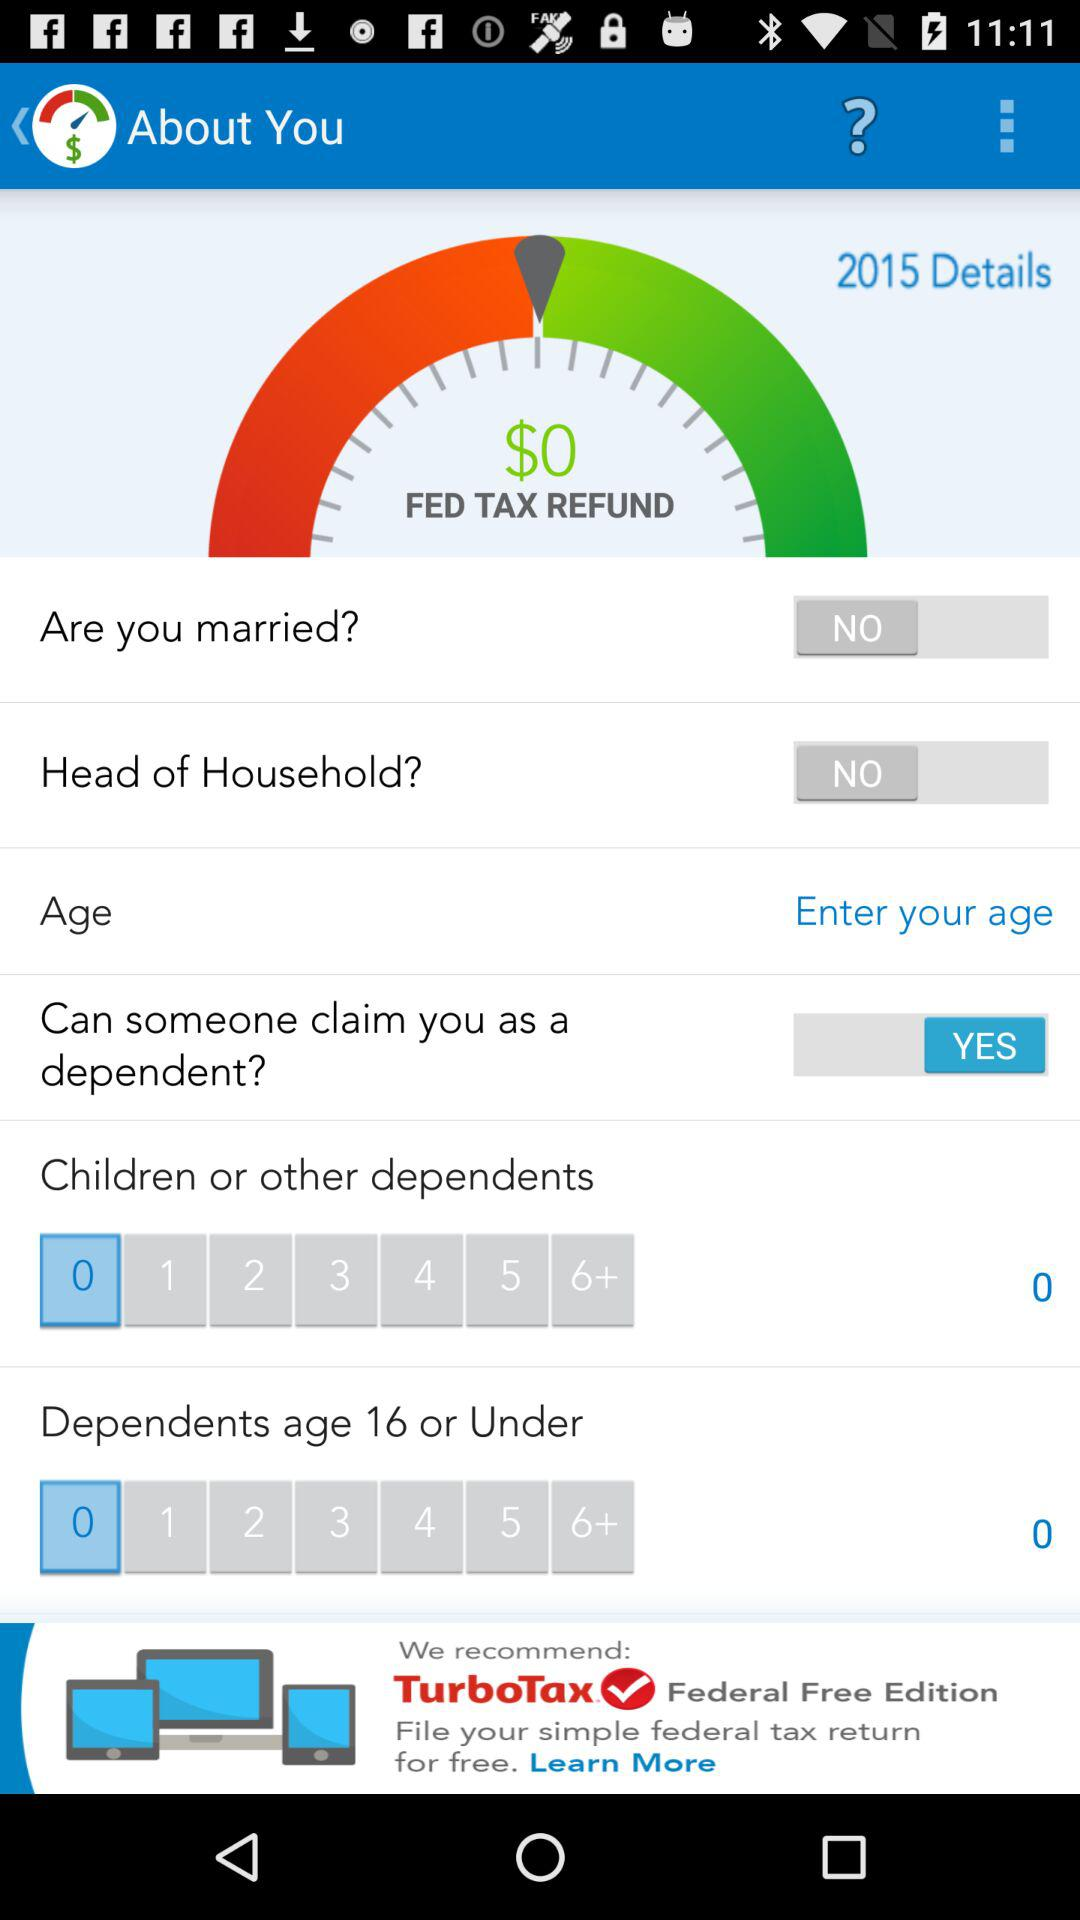What is the count of "Dependents age 16 or Under"? The count of "Dependents age 16 or Under" is 0. 